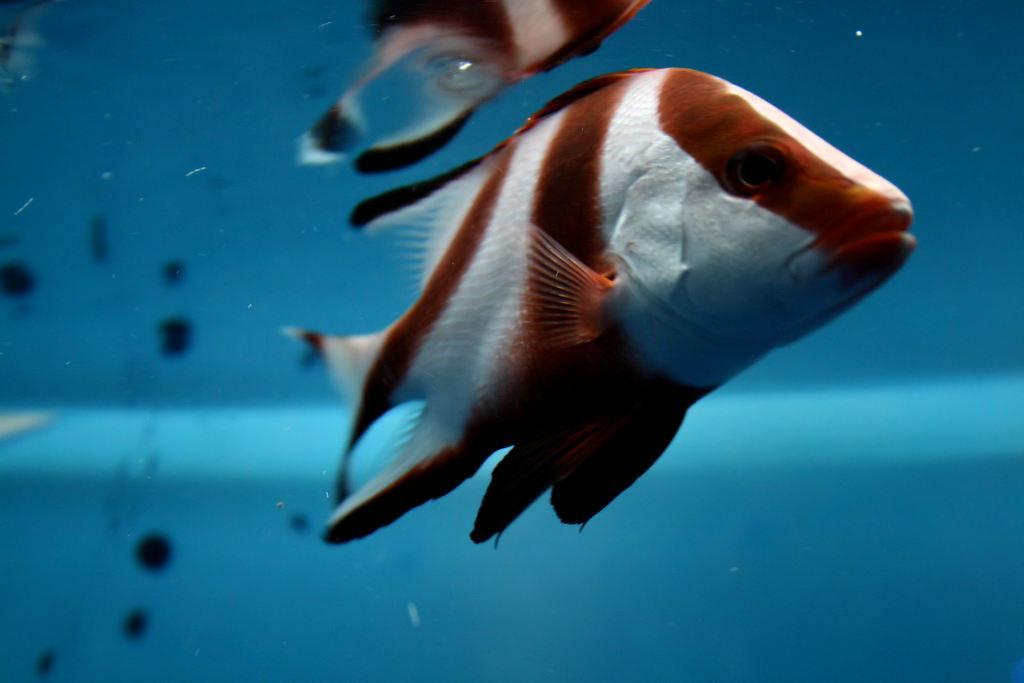How would you summarize this image in a sentence or two? This is a zoomed in picture. On the right we can see the two fishes swimming in the water body. In the background we can see there are some other objects. 